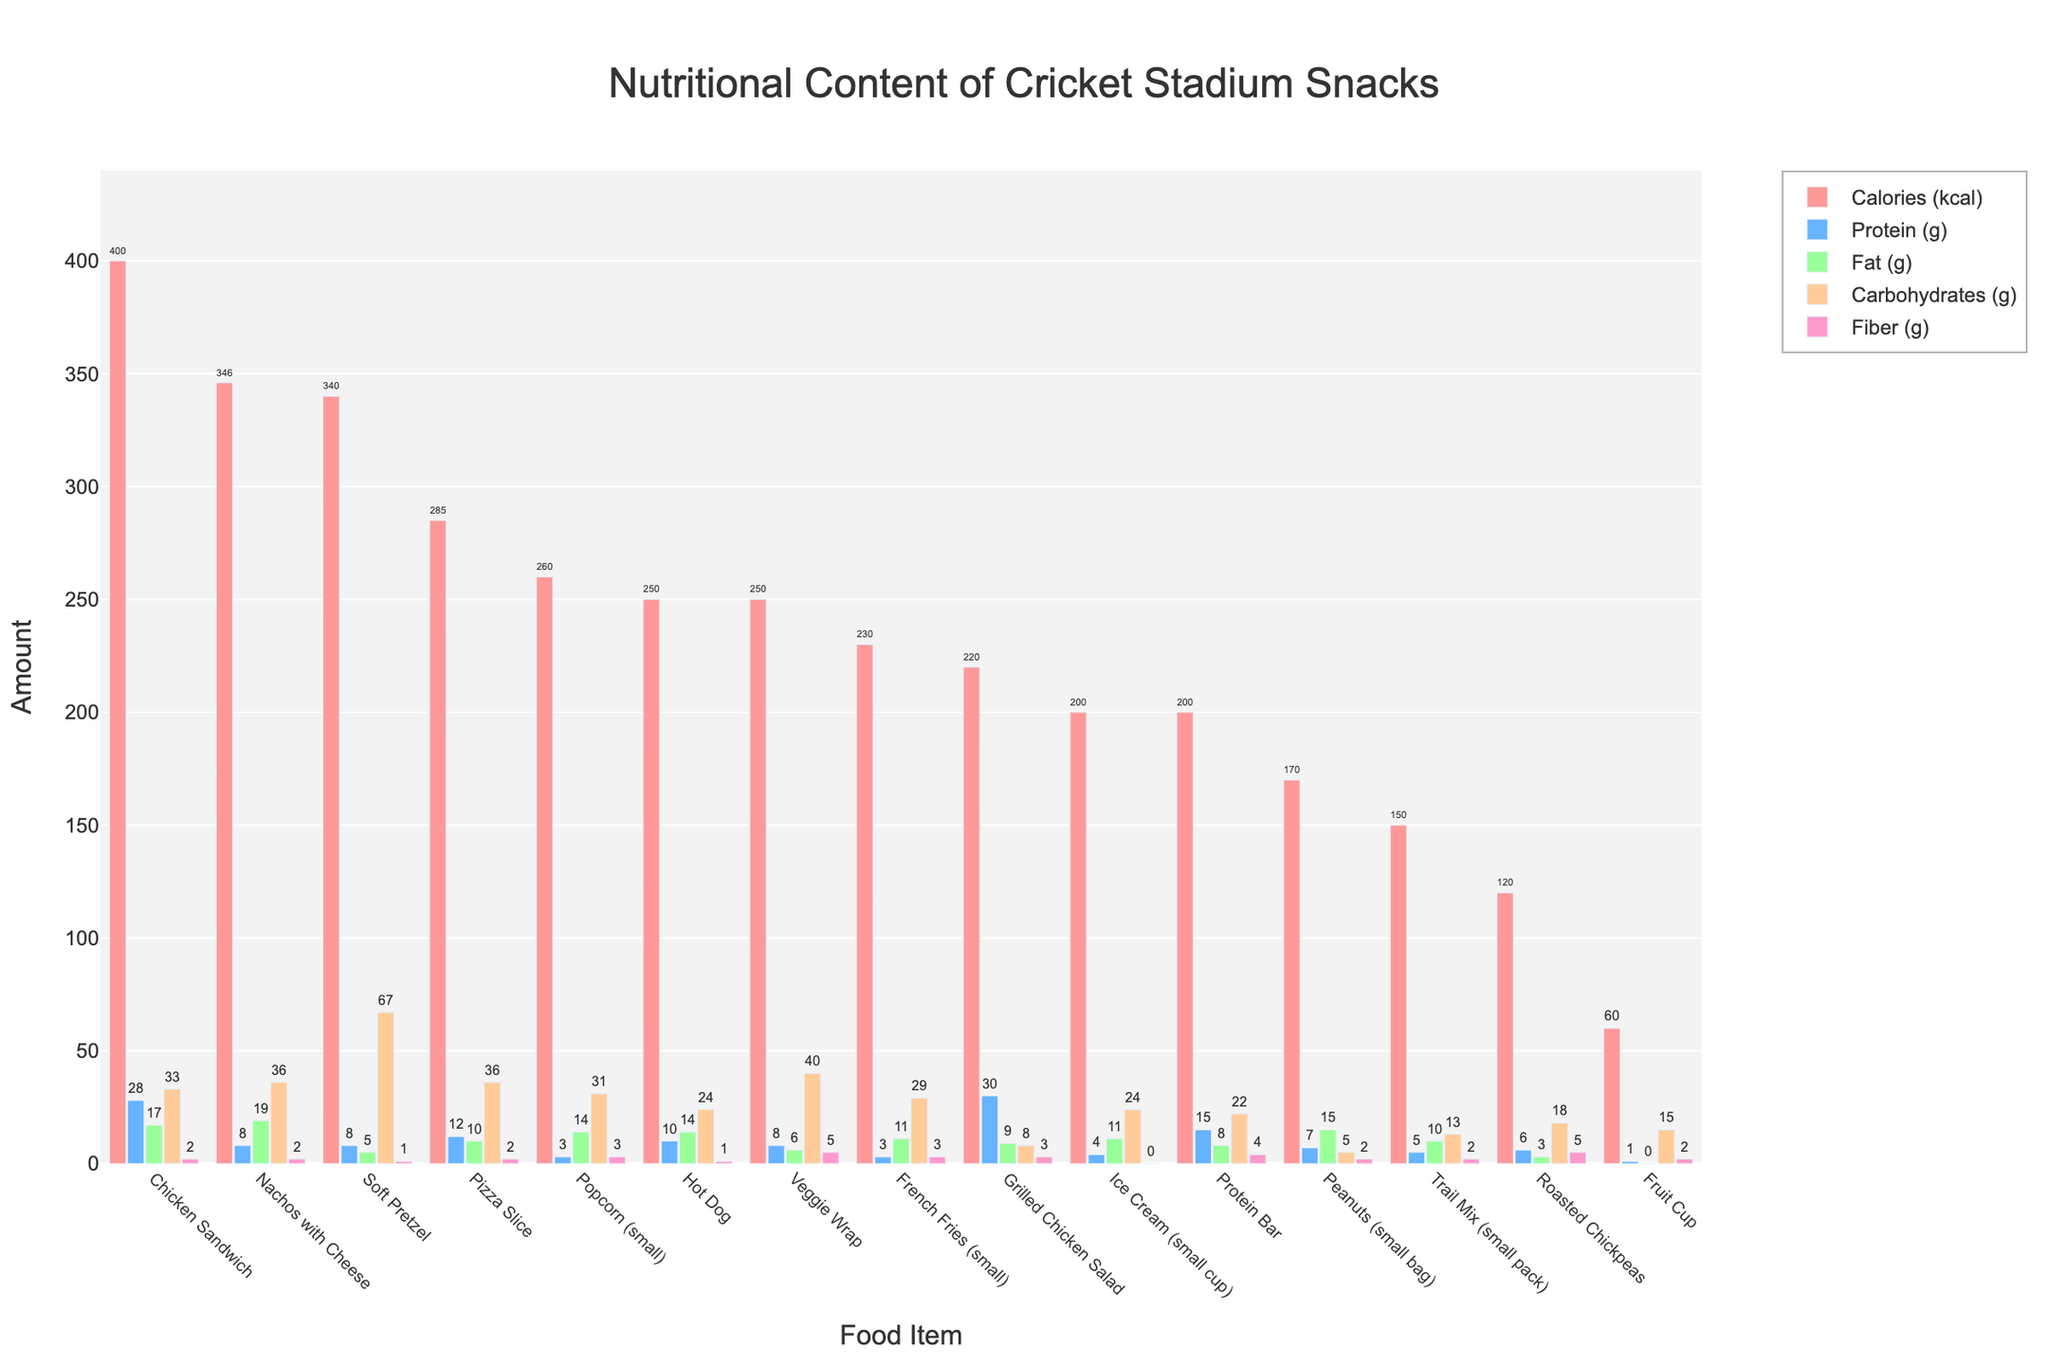Which food item has the highest calorie content? By looking at the heights of the bars for calories, the Chicken Sandwich has the highest calorie content. It surpasses other items clearly.
Answer: Chicken Sandwich How do the protein content of the Protein Bar and the Chicken Sandwich compare? Comparing the height of the bars labeled Protein (g), the Chicken Sandwich has a slightly higher bar than the Protein Bar which indicates higher protein content.
Answer: Chicken Sandwich What is the total fiber content of Popcorn (small), Veggie Wrap, and Roasted Chickpeas combined? Summing the height of the bars labeled Fiber (g) for these items: 3g (Popcorn) + 5g (Veggie Wrap) + 5g (Roasted Chickpeas) = 13g.
Answer: 13g Which food item has the least fat content? By finding the shortest bar labeled Fat (g), the Fruit Cup shows the least height among them all.
Answer: Fruit Cup Between Nachos with Cheese and Pizza Slice, which one has higher carbohydrate content? Comparing their carbohydrate bars, Nachos with Cheese has a slightly shorter bar than the Pizza Slice, indicating lower carbohydrate content for the Nachos.
Answer: Pizza Slice If you eat a Grilled Chicken Salad and an Ice Cream (small cup), what’s the combined protein intake? Summing up the protein bars for Grilled Chicken Salad (30g) and Ice Cream (4g): 30g + 4g = 34g.
Answer: 34g Which has more fiber, the Soft Pretzel or the Hot Dog? Comparing the height of their fiber bars, the Hot Dog appears to have a higher bar than the Soft Pretzel.
Answer: Hot Dog What is the average calorie content of a Fruit Cup, Trail Mix, and Peanuts (small bag)? Adding the calories and dividing by the number of items: 60 (Fruit Cup) + 150 (Trail Mix) + 170 (Peanuts) = 380. Dividing by 3: 380 / 3 ≈ 126.67.
Answer: 126.67 Comparing French Fries (small) and Soft Pretzel, which has more fat content? By comparing the fat bars, the French Fries have a higher bar than the Soft Pretzel, indicating more fat content.
Answer: French Fries Which food item has the lowest carbohydrate content? Observing the carbohydrate bars, Roasted Chickpeas have the shortest bar indicating the lowest carbohydrate content.
Answer: Roasted Chickpeas 